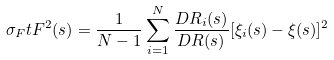<formula> <loc_0><loc_0><loc_500><loc_500>\sigma _ { F } t F ^ { 2 } ( s ) = \frac { 1 } { N - 1 } \sum _ { i = 1 } ^ { N } \frac { D R _ { i } ( s ) } { D R ( s ) } [ \xi _ { i } ( s ) - \xi ( s ) ] ^ { 2 }</formula> 